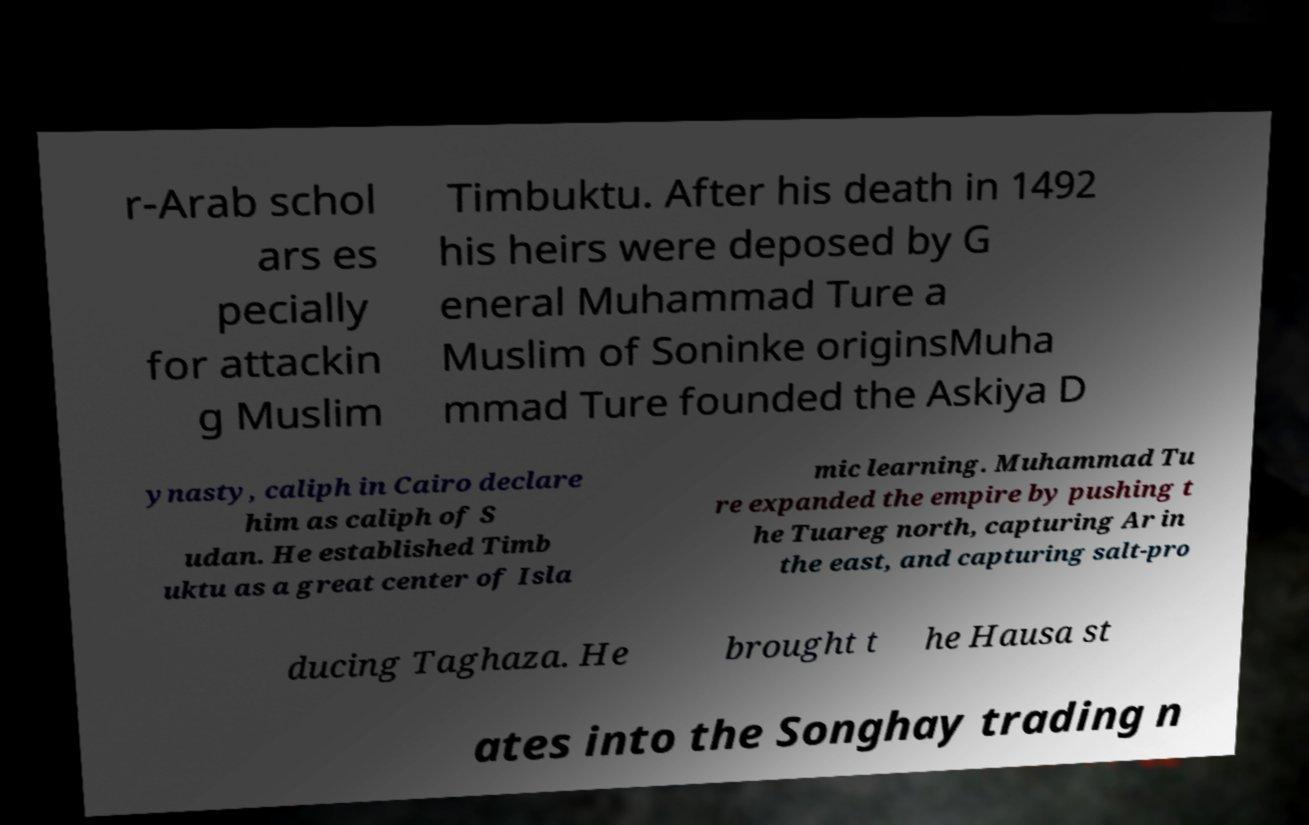For documentation purposes, I need the text within this image transcribed. Could you provide that? r-Arab schol ars es pecially for attackin g Muslim Timbuktu. After his death in 1492 his heirs were deposed by G eneral Muhammad Ture a Muslim of Soninke originsMuha mmad Ture founded the Askiya D ynasty, caliph in Cairo declare him as caliph of S udan. He established Timb uktu as a great center of Isla mic learning. Muhammad Tu re expanded the empire by pushing t he Tuareg north, capturing Ar in the east, and capturing salt-pro ducing Taghaza. He brought t he Hausa st ates into the Songhay trading n 